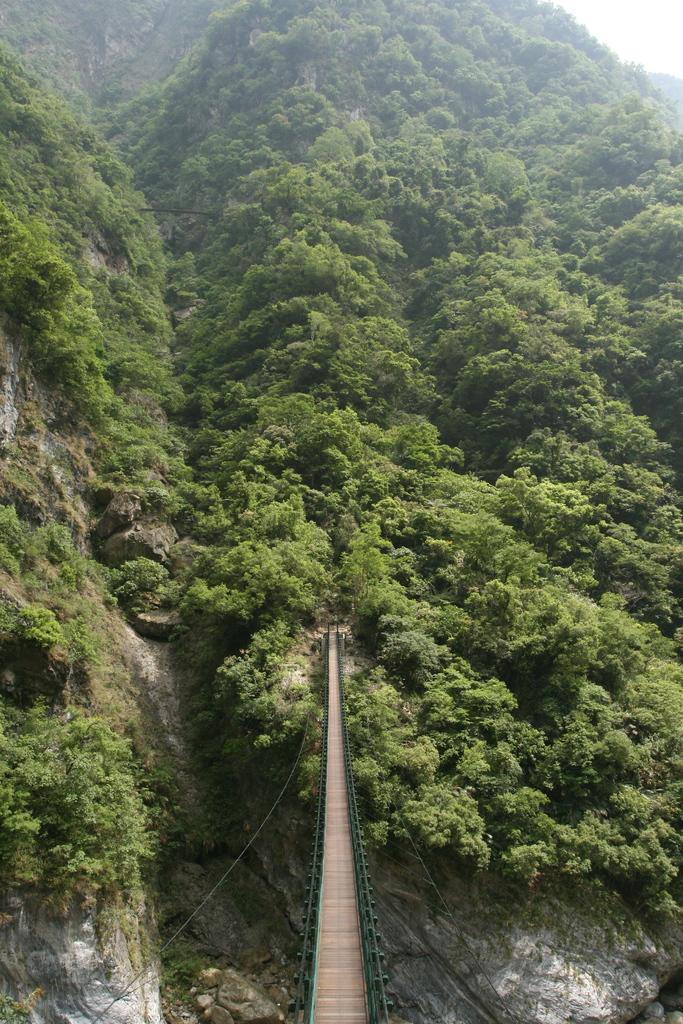What is the main feature of the image? There is a walkway in the image. What can be seen at the bottom of the image? There are rocks visible at the bottom of the image. What type of natural environment is visible in the background of the image? There are trees visible in the background of the image. What month is the hen laying eggs in the image? There is no hen or eggs present in the image, so it is not possible to determine the month. 